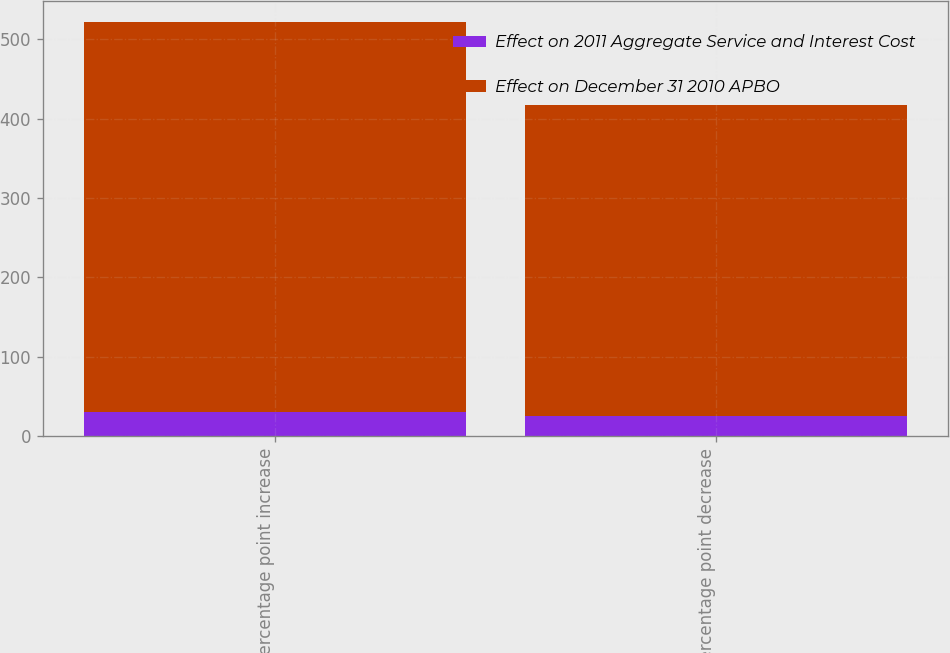Convert chart to OTSL. <chart><loc_0><loc_0><loc_500><loc_500><stacked_bar_chart><ecel><fcel>One percentage point increase<fcel>One percentage point decrease<nl><fcel>Effect on 2011 Aggregate Service and Interest Cost<fcel>31<fcel>25<nl><fcel>Effect on December 31 2010 APBO<fcel>491<fcel>392<nl></chart> 